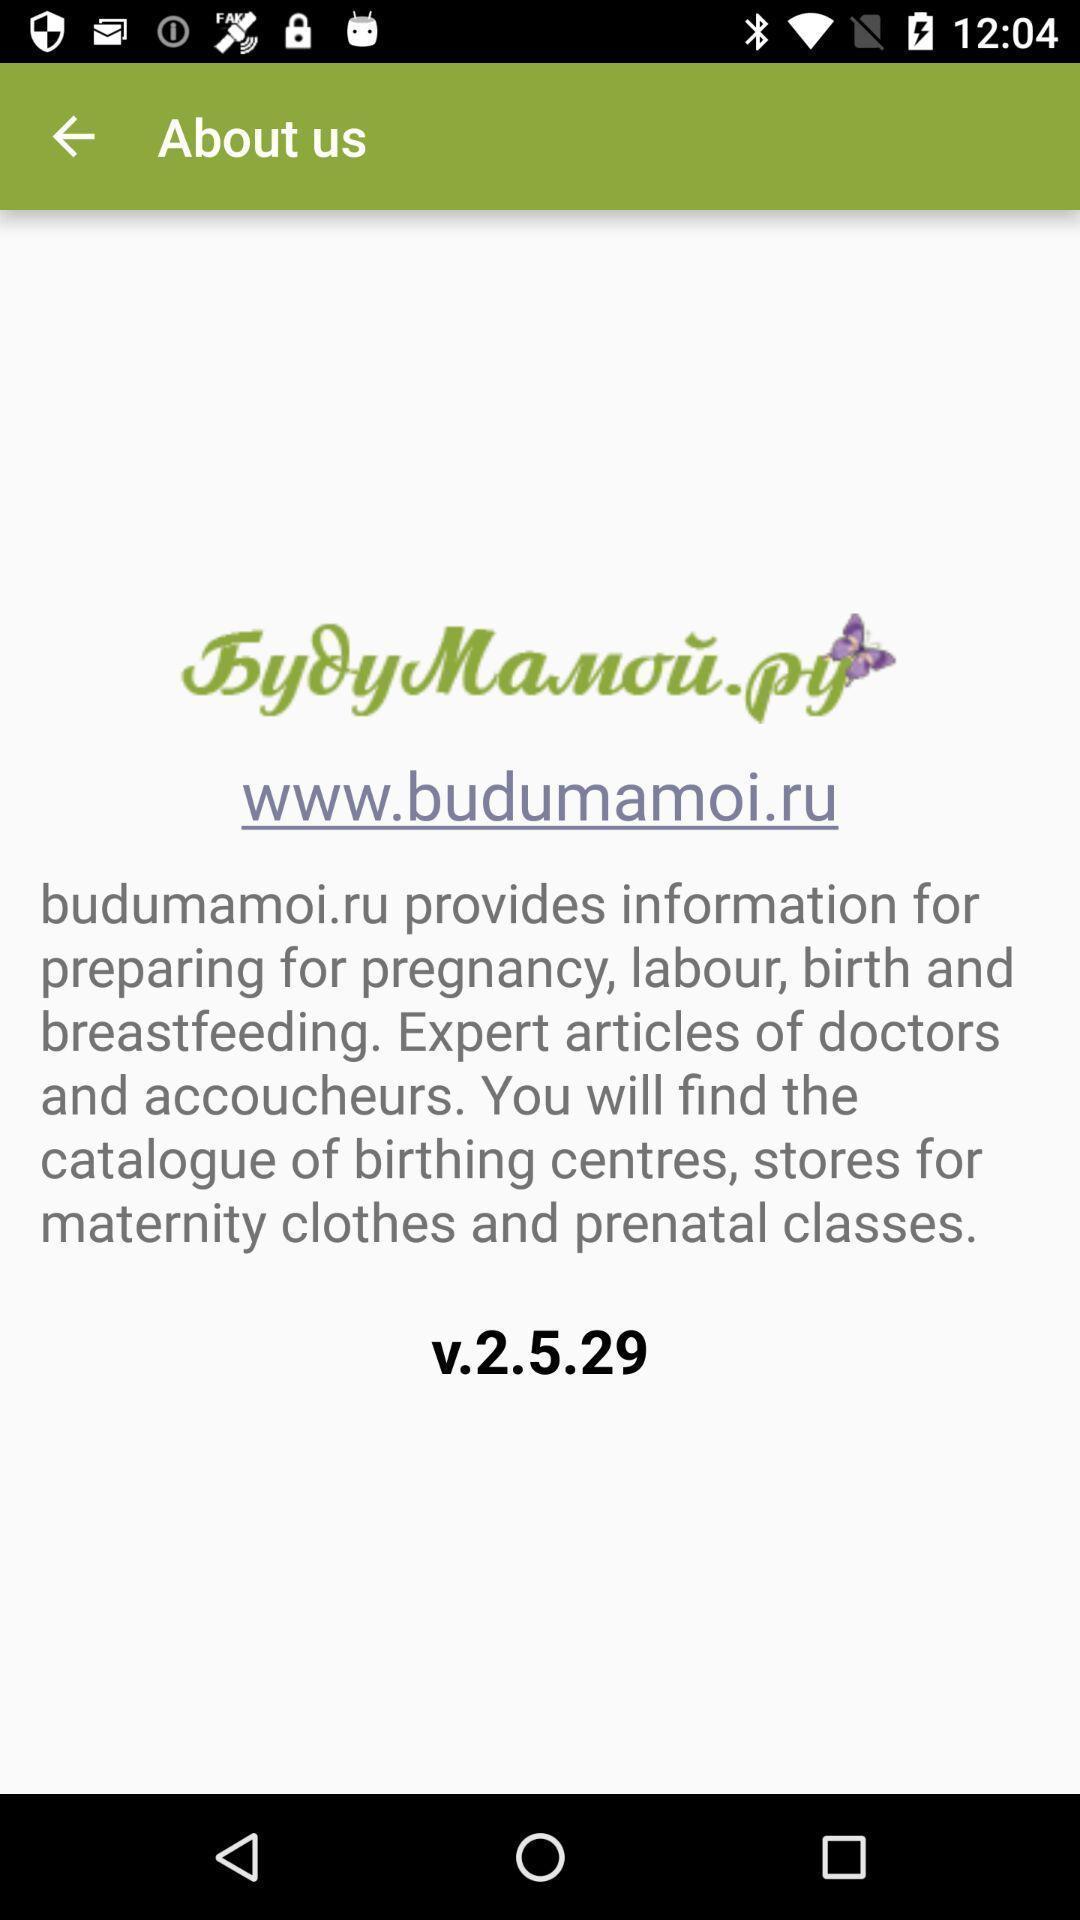Summarize the main components in this picture. Screen showing general information on a device. 